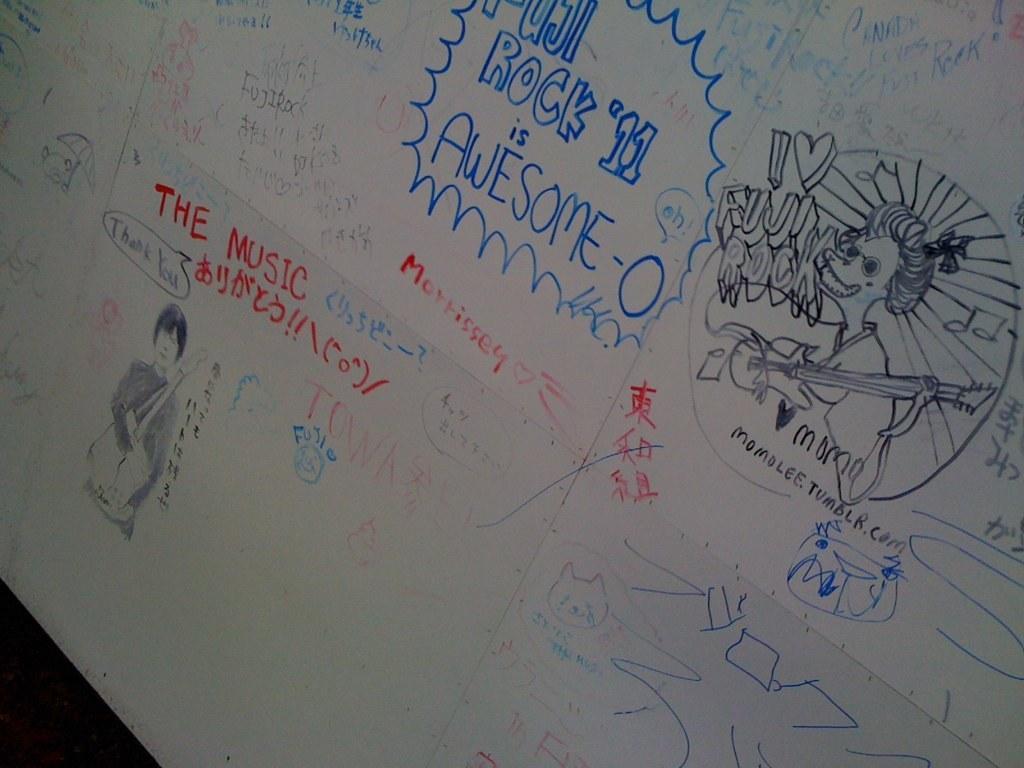How would you summarize this image in a sentence or two? In this image we can see some sketches which are drawn with color pencils and there are some proverbs and quotes. 